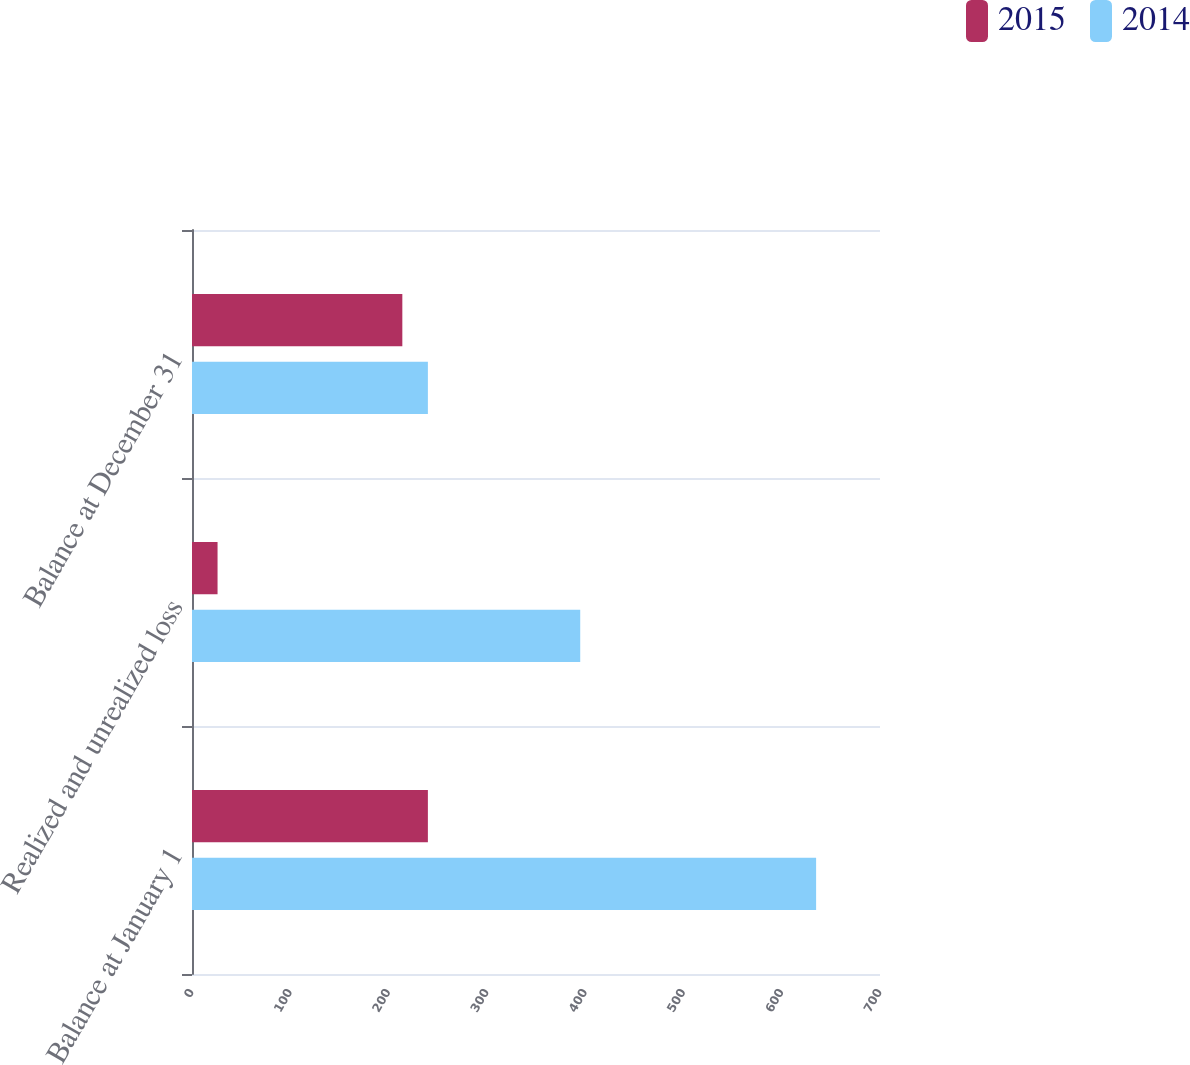<chart> <loc_0><loc_0><loc_500><loc_500><stacked_bar_chart><ecel><fcel>Balance at January 1<fcel>Realized and unrealized loss<fcel>Balance at December 31<nl><fcel>2015<fcel>240<fcel>26<fcel>214<nl><fcel>2014<fcel>635<fcel>395<fcel>240<nl></chart> 